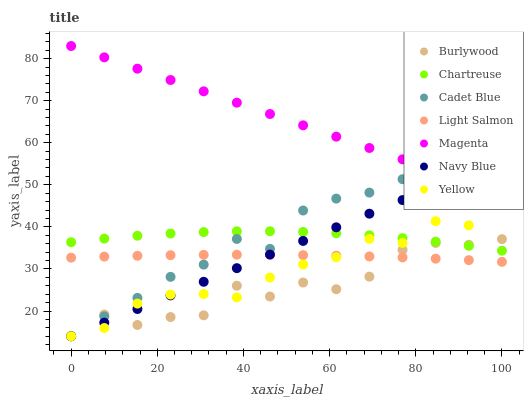Does Burlywood have the minimum area under the curve?
Answer yes or no. Yes. Does Magenta have the maximum area under the curve?
Answer yes or no. Yes. Does Cadet Blue have the minimum area under the curve?
Answer yes or no. No. Does Cadet Blue have the maximum area under the curve?
Answer yes or no. No. Is Navy Blue the smoothest?
Answer yes or no. Yes. Is Burlywood the roughest?
Answer yes or no. Yes. Is Cadet Blue the smoothest?
Answer yes or no. No. Is Cadet Blue the roughest?
Answer yes or no. No. Does Cadet Blue have the lowest value?
Answer yes or no. Yes. Does Chartreuse have the lowest value?
Answer yes or no. No. Does Magenta have the highest value?
Answer yes or no. Yes. Does Cadet Blue have the highest value?
Answer yes or no. No. Is Light Salmon less than Magenta?
Answer yes or no. Yes. Is Magenta greater than Yellow?
Answer yes or no. Yes. Does Light Salmon intersect Cadet Blue?
Answer yes or no. Yes. Is Light Salmon less than Cadet Blue?
Answer yes or no. No. Is Light Salmon greater than Cadet Blue?
Answer yes or no. No. Does Light Salmon intersect Magenta?
Answer yes or no. No. 